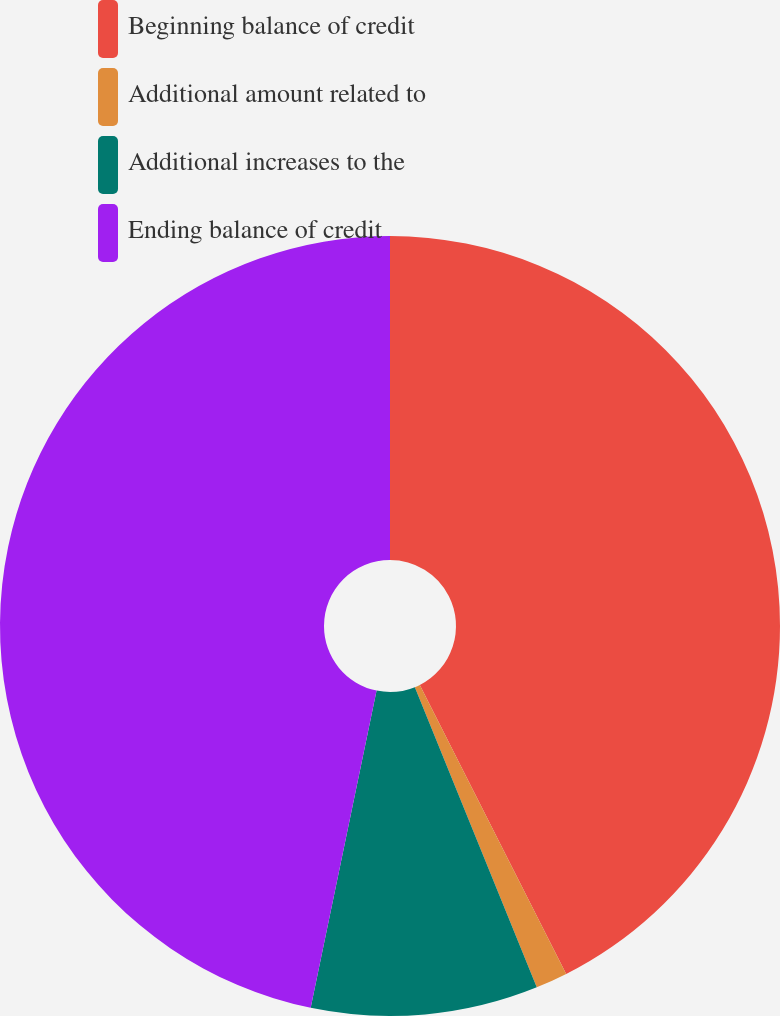<chart> <loc_0><loc_0><loc_500><loc_500><pie_chart><fcel>Beginning balance of credit<fcel>Additional amount related to<fcel>Additional increases to the<fcel>Ending balance of credit<nl><fcel>42.54%<fcel>1.32%<fcel>9.4%<fcel>46.74%<nl></chart> 